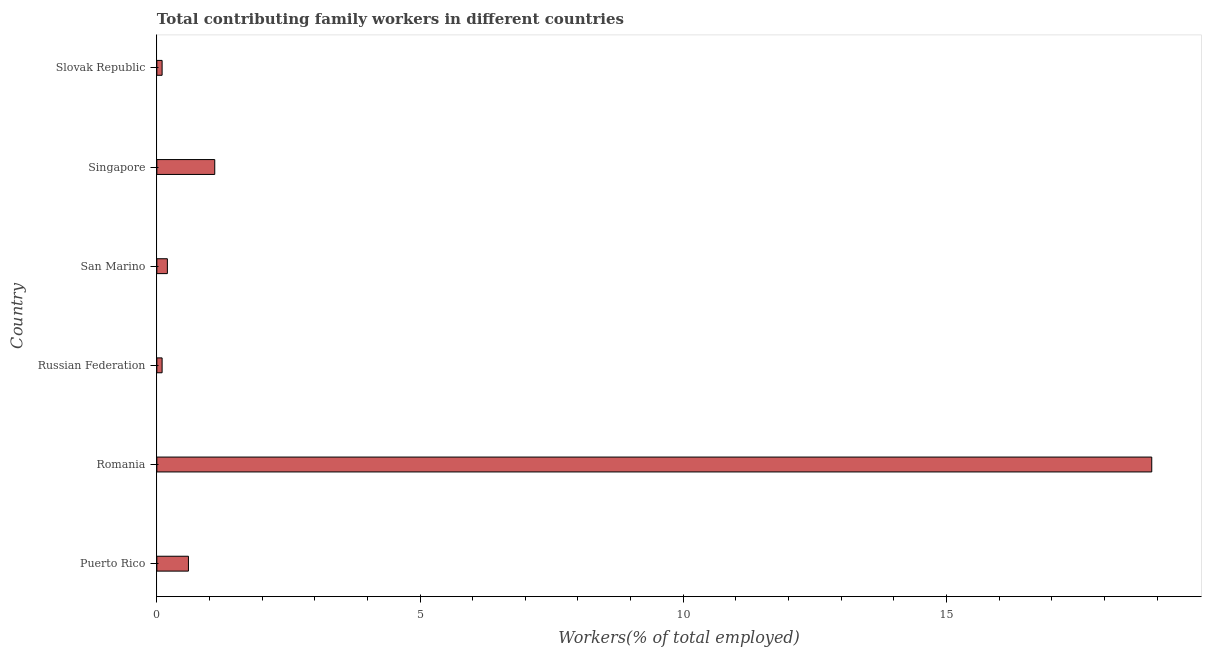Does the graph contain grids?
Your answer should be very brief. No. What is the title of the graph?
Your answer should be very brief. Total contributing family workers in different countries. What is the label or title of the X-axis?
Give a very brief answer. Workers(% of total employed). What is the label or title of the Y-axis?
Your answer should be compact. Country. What is the contributing family workers in Slovak Republic?
Your response must be concise. 0.1. Across all countries, what is the maximum contributing family workers?
Ensure brevity in your answer.  18.9. Across all countries, what is the minimum contributing family workers?
Offer a terse response. 0.1. In which country was the contributing family workers maximum?
Provide a short and direct response. Romania. In which country was the contributing family workers minimum?
Provide a succinct answer. Russian Federation. What is the sum of the contributing family workers?
Give a very brief answer. 21. What is the average contributing family workers per country?
Your answer should be very brief. 3.5. What is the median contributing family workers?
Provide a succinct answer. 0.4. What is the ratio of the contributing family workers in Russian Federation to that in Singapore?
Your answer should be compact. 0.09. Is the difference between the contributing family workers in Russian Federation and Slovak Republic greater than the difference between any two countries?
Ensure brevity in your answer.  No. What is the difference between the highest and the second highest contributing family workers?
Your answer should be compact. 17.8. How many countries are there in the graph?
Offer a terse response. 6. Are the values on the major ticks of X-axis written in scientific E-notation?
Provide a succinct answer. No. What is the Workers(% of total employed) of Puerto Rico?
Your answer should be compact. 0.6. What is the Workers(% of total employed) of Romania?
Ensure brevity in your answer.  18.9. What is the Workers(% of total employed) in Russian Federation?
Your response must be concise. 0.1. What is the Workers(% of total employed) in San Marino?
Give a very brief answer. 0.2. What is the Workers(% of total employed) of Singapore?
Give a very brief answer. 1.1. What is the Workers(% of total employed) in Slovak Republic?
Ensure brevity in your answer.  0.1. What is the difference between the Workers(% of total employed) in Puerto Rico and Romania?
Your answer should be compact. -18.3. What is the difference between the Workers(% of total employed) in Puerto Rico and Singapore?
Make the answer very short. -0.5. What is the difference between the Workers(% of total employed) in Puerto Rico and Slovak Republic?
Your answer should be very brief. 0.5. What is the difference between the Workers(% of total employed) in Romania and Singapore?
Your response must be concise. 17.8. What is the difference between the Workers(% of total employed) in Romania and Slovak Republic?
Give a very brief answer. 18.8. What is the difference between the Workers(% of total employed) in Russian Federation and Singapore?
Your answer should be very brief. -1. What is the difference between the Workers(% of total employed) in Russian Federation and Slovak Republic?
Your answer should be very brief. 0. What is the difference between the Workers(% of total employed) in San Marino and Singapore?
Give a very brief answer. -0.9. What is the difference between the Workers(% of total employed) in San Marino and Slovak Republic?
Ensure brevity in your answer.  0.1. What is the difference between the Workers(% of total employed) in Singapore and Slovak Republic?
Keep it short and to the point. 1. What is the ratio of the Workers(% of total employed) in Puerto Rico to that in Romania?
Offer a terse response. 0.03. What is the ratio of the Workers(% of total employed) in Puerto Rico to that in Singapore?
Your answer should be compact. 0.55. What is the ratio of the Workers(% of total employed) in Romania to that in Russian Federation?
Your response must be concise. 189. What is the ratio of the Workers(% of total employed) in Romania to that in San Marino?
Make the answer very short. 94.5. What is the ratio of the Workers(% of total employed) in Romania to that in Singapore?
Give a very brief answer. 17.18. What is the ratio of the Workers(% of total employed) in Romania to that in Slovak Republic?
Make the answer very short. 189. What is the ratio of the Workers(% of total employed) in Russian Federation to that in Singapore?
Ensure brevity in your answer.  0.09. What is the ratio of the Workers(% of total employed) in San Marino to that in Singapore?
Ensure brevity in your answer.  0.18. What is the ratio of the Workers(% of total employed) in Singapore to that in Slovak Republic?
Give a very brief answer. 11. 